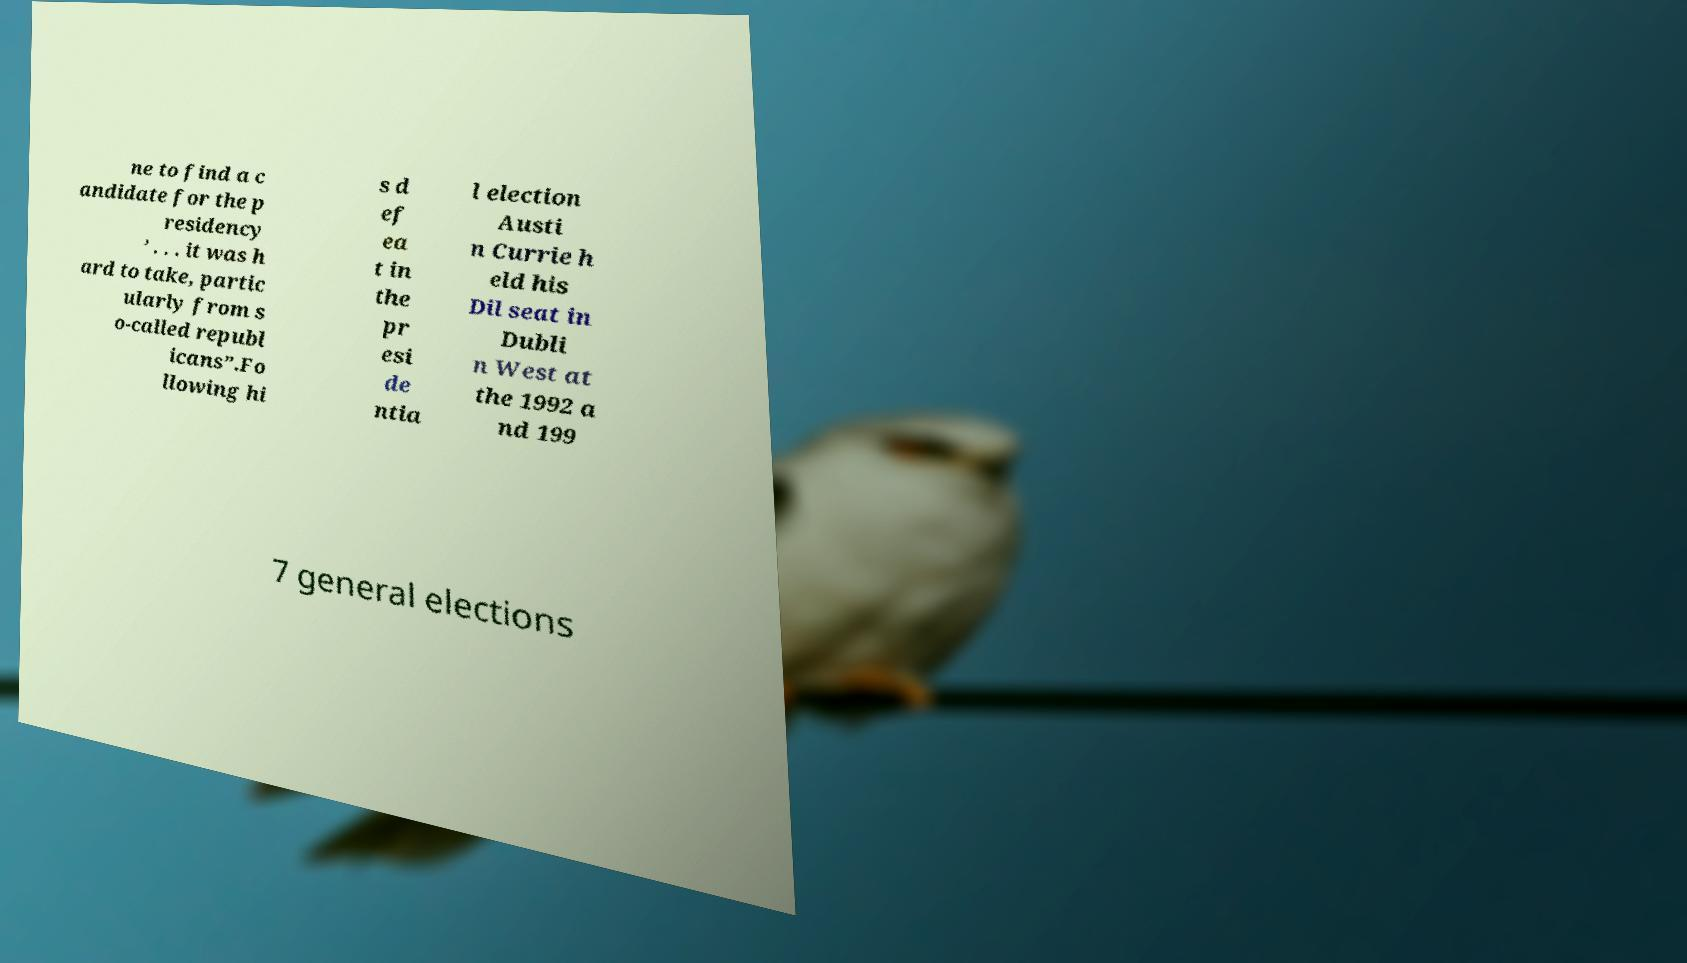I need the written content from this picture converted into text. Can you do that? ne to find a c andidate for the p residency ’ . . . it was h ard to take, partic ularly from s o-called republ icans”.Fo llowing hi s d ef ea t in the pr esi de ntia l election Austi n Currie h eld his Dil seat in Dubli n West at the 1992 a nd 199 7 general elections 